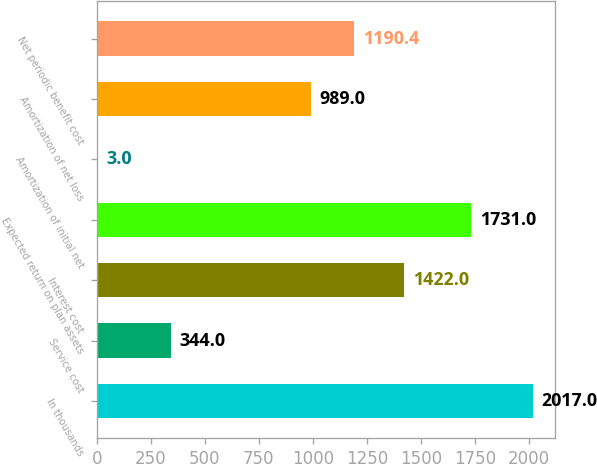Convert chart. <chart><loc_0><loc_0><loc_500><loc_500><bar_chart><fcel>In thousands<fcel>Service cost<fcel>Interest cost<fcel>Expected return on plan assets<fcel>Amortization of initial net<fcel>Amortization of net loss<fcel>Net periodic benefit cost<nl><fcel>2017<fcel>344<fcel>1422<fcel>1731<fcel>3<fcel>989<fcel>1190.4<nl></chart> 